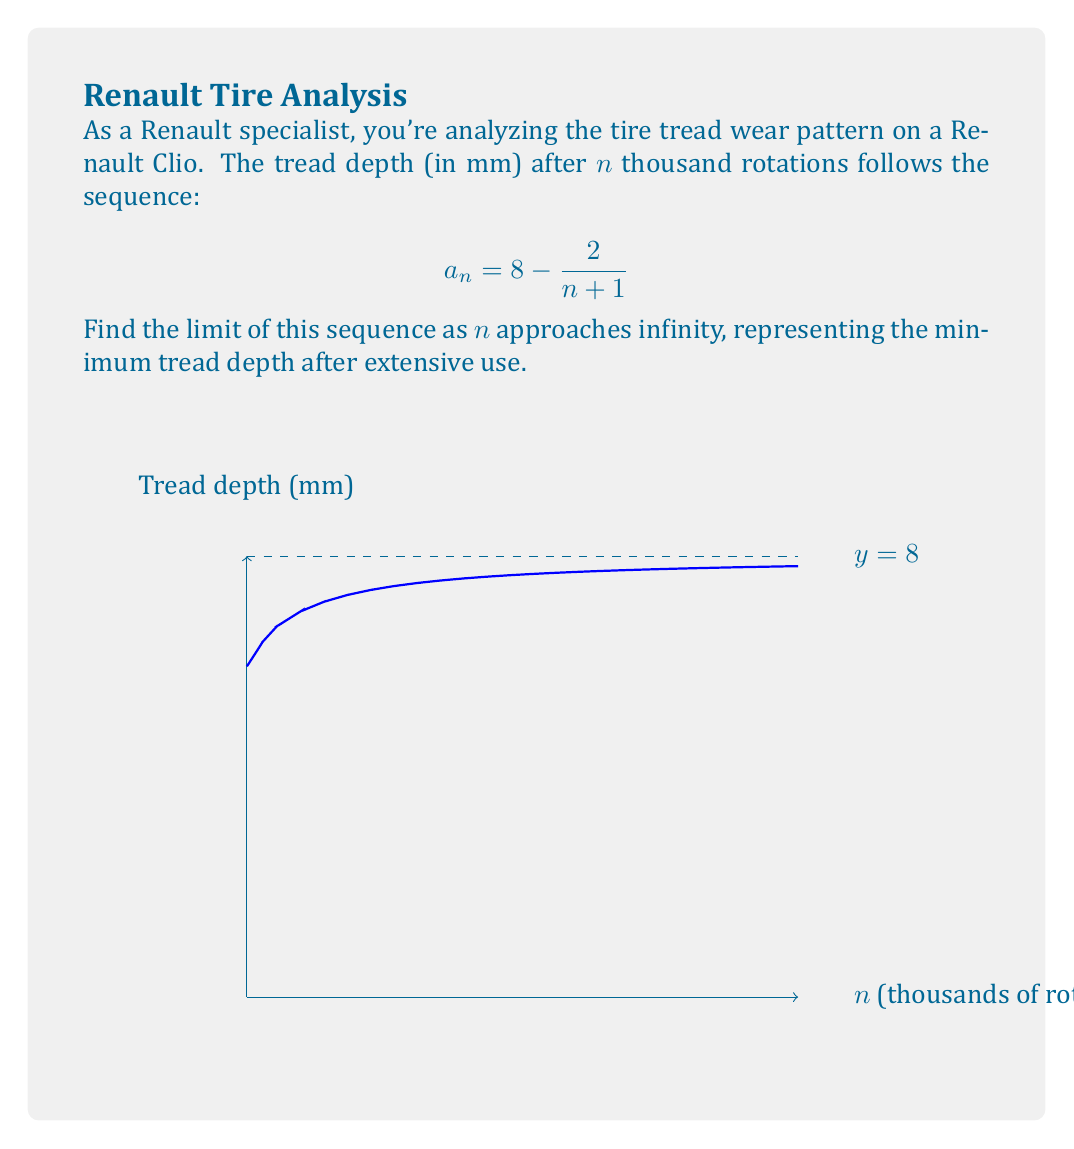Show me your answer to this math problem. Let's approach this step-by-step:

1) We're given the sequence $a_n = 8 - \frac{2}{n+1}$

2) To find the limit as n approaches infinity, we need to evaluate:
   $$\lim_{n \to \infty} \left(8 - \frac{2}{n+1}\right)$$

3) We can split this into two parts:
   $$\lim_{n \to \infty} 8 - \lim_{n \to \infty} \frac{2}{n+1}$$

4) The limit of a constant is the constant itself:
   $$8 - \lim_{n \to \infty} \frac{2}{n+1}$$

5) As n approaches infinity, (n+1) also approaches infinity. Any finite number divided by infinity approaches zero:
   $$\lim_{n \to \infty} \frac{2}{n+1} = 0$$

6) Therefore, our limit becomes:
   $$8 - 0 = 8$$

This means that after a very large number of rotations, the tread depth approaches 8 mm asymptotically, never quite reaching it but getting arbitrarily close.
Answer: 8 mm 